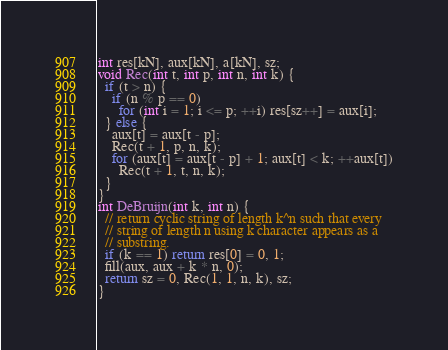<code> <loc_0><loc_0><loc_500><loc_500><_C++_>int res[kN], aux[kN], a[kN], sz;
void Rec(int t, int p, int n, int k) {
  if (t > n) {
    if (n % p == 0)
      for (int i = 1; i <= p; ++i) res[sz++] = aux[i];
  } else {
    aux[t] = aux[t - p];
    Rec(t + 1, p, n, k);
    for (aux[t] = aux[t - p] + 1; aux[t] < k; ++aux[t])
      Rec(t + 1, t, n, k);
  }
}
int DeBruijn(int k, int n) {
  // return cyclic string of length k^n such that every
  // string of length n using k character appears as a
  // substring.
  if (k == 1) return res[0] = 0, 1;
  fill(aux, aux + k * n, 0);
  return sz = 0, Rec(1, 1, n, k), sz;
}
</code> 